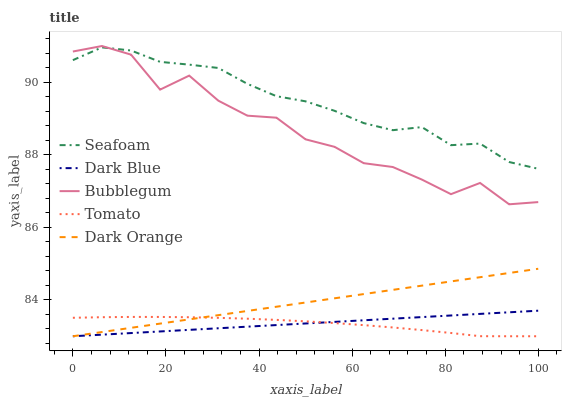Does Tomato have the minimum area under the curve?
Answer yes or no. Yes. Does Seafoam have the maximum area under the curve?
Answer yes or no. Yes. Does Dark Blue have the minimum area under the curve?
Answer yes or no. No. Does Dark Blue have the maximum area under the curve?
Answer yes or no. No. Is Dark Blue the smoothest?
Answer yes or no. Yes. Is Bubblegum the roughest?
Answer yes or no. Yes. Is Seafoam the smoothest?
Answer yes or no. No. Is Seafoam the roughest?
Answer yes or no. No. Does Tomato have the lowest value?
Answer yes or no. Yes. Does Seafoam have the lowest value?
Answer yes or no. No. Does Bubblegum have the highest value?
Answer yes or no. Yes. Does Dark Blue have the highest value?
Answer yes or no. No. Is Tomato less than Seafoam?
Answer yes or no. Yes. Is Bubblegum greater than Dark Blue?
Answer yes or no. Yes. Does Dark Orange intersect Dark Blue?
Answer yes or no. Yes. Is Dark Orange less than Dark Blue?
Answer yes or no. No. Is Dark Orange greater than Dark Blue?
Answer yes or no. No. Does Tomato intersect Seafoam?
Answer yes or no. No. 